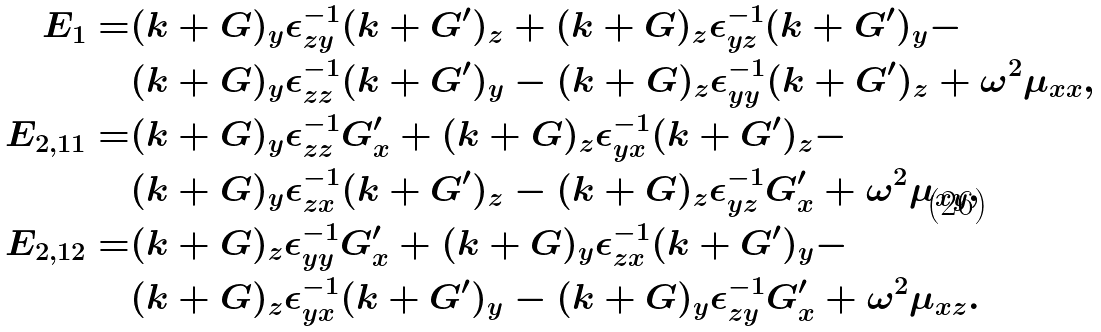Convert formula to latex. <formula><loc_0><loc_0><loc_500><loc_500>E _ { 1 } = & ( k + G ) _ { y } \epsilon ^ { - 1 } _ { z y } ( k + G ^ { \prime } ) _ { z } + ( k + G ) _ { z } \epsilon ^ { - 1 } _ { y z } ( k + G ^ { \prime } ) _ { y } - \\ & ( k + G ) _ { y } \epsilon ^ { - 1 } _ { z z } ( k + G ^ { \prime } ) _ { y } - ( k + G ) _ { z } \epsilon ^ { - 1 } _ { y y } ( k + G ^ { \prime } ) _ { z } + \omega ^ { 2 } \mu _ { x x } , \\ E _ { 2 , 1 1 } = & ( k + G ) _ { y } \epsilon ^ { - 1 } _ { z z } G _ { x } ^ { \prime } + ( k + G ) _ { z } \epsilon ^ { - 1 } _ { y x } ( k + G ^ { \prime } ) _ { z } - \\ & ( k + G ) _ { y } \epsilon ^ { - 1 } _ { z x } ( k + G ^ { \prime } ) _ { z } - ( k + G ) _ { z } \epsilon ^ { - 1 } _ { y z } G _ { x } ^ { \prime } + \omega ^ { 2 } \mu _ { x y } , \\ E _ { 2 , 1 2 } = & ( k + G ) _ { z } \epsilon ^ { - 1 } _ { y y } G _ { x } ^ { \prime } + ( k + G ) _ { y } \epsilon ^ { - 1 } _ { z x } ( k + G ^ { \prime } ) _ { y } - \\ & ( k + G ) _ { z } \epsilon ^ { - 1 } _ { y x } ( k + G ^ { \prime } ) _ { y } - ( k + G ) _ { y } \epsilon ^ { - 1 } _ { z y } G _ { x } ^ { \prime } + \omega ^ { 2 } \mu _ { x z } .</formula> 